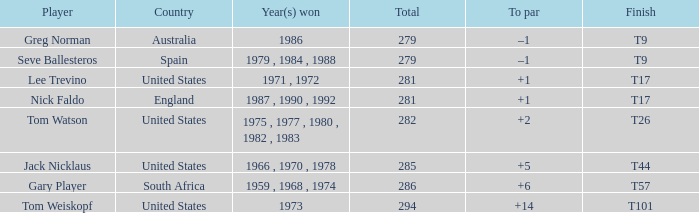Which country had a total of 282? United States. 